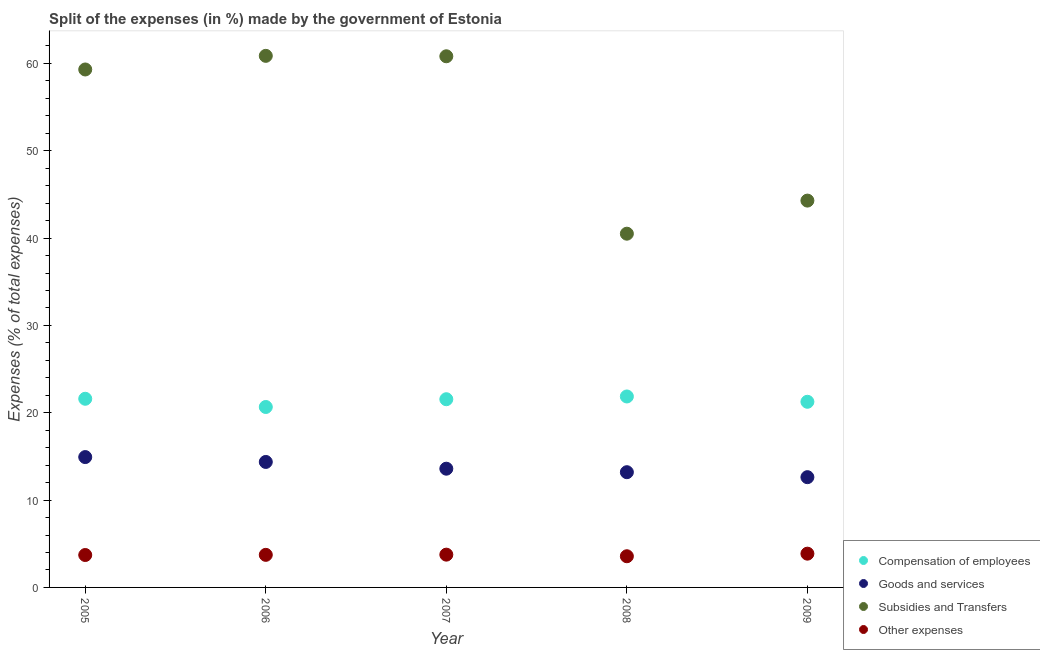How many different coloured dotlines are there?
Offer a terse response. 4. What is the percentage of amount spent on subsidies in 2006?
Make the answer very short. 60.87. Across all years, what is the maximum percentage of amount spent on subsidies?
Offer a terse response. 60.87. Across all years, what is the minimum percentage of amount spent on goods and services?
Your response must be concise. 12.63. In which year was the percentage of amount spent on other expenses maximum?
Keep it short and to the point. 2009. In which year was the percentage of amount spent on other expenses minimum?
Ensure brevity in your answer.  2008. What is the total percentage of amount spent on compensation of employees in the graph?
Ensure brevity in your answer.  106.94. What is the difference between the percentage of amount spent on other expenses in 2005 and that in 2007?
Ensure brevity in your answer.  -0.04. What is the difference between the percentage of amount spent on subsidies in 2006 and the percentage of amount spent on other expenses in 2008?
Your answer should be very brief. 57.3. What is the average percentage of amount spent on other expenses per year?
Keep it short and to the point. 3.73. In the year 2006, what is the difference between the percentage of amount spent on goods and services and percentage of amount spent on compensation of employees?
Ensure brevity in your answer.  -6.29. What is the ratio of the percentage of amount spent on other expenses in 2005 to that in 2007?
Make the answer very short. 0.99. What is the difference between the highest and the second highest percentage of amount spent on subsidies?
Give a very brief answer. 0.05. What is the difference between the highest and the lowest percentage of amount spent on goods and services?
Ensure brevity in your answer.  2.3. Is it the case that in every year, the sum of the percentage of amount spent on compensation of employees and percentage of amount spent on goods and services is greater than the percentage of amount spent on subsidies?
Give a very brief answer. No. Does the percentage of amount spent on goods and services monotonically increase over the years?
Provide a short and direct response. No. Is the percentage of amount spent on compensation of employees strictly greater than the percentage of amount spent on subsidies over the years?
Make the answer very short. No. How many years are there in the graph?
Make the answer very short. 5. Are the values on the major ticks of Y-axis written in scientific E-notation?
Your response must be concise. No. Does the graph contain grids?
Make the answer very short. No. How many legend labels are there?
Give a very brief answer. 4. What is the title of the graph?
Keep it short and to the point. Split of the expenses (in %) made by the government of Estonia. Does "Public sector management" appear as one of the legend labels in the graph?
Ensure brevity in your answer.  No. What is the label or title of the Y-axis?
Ensure brevity in your answer.  Expenses (% of total expenses). What is the Expenses (% of total expenses) in Compensation of employees in 2005?
Provide a succinct answer. 21.6. What is the Expenses (% of total expenses) in Goods and services in 2005?
Offer a terse response. 14.93. What is the Expenses (% of total expenses) in Subsidies and Transfers in 2005?
Provide a short and direct response. 59.31. What is the Expenses (% of total expenses) of Other expenses in 2005?
Your answer should be compact. 3.71. What is the Expenses (% of total expenses) of Compensation of employees in 2006?
Your answer should be compact. 20.66. What is the Expenses (% of total expenses) in Goods and services in 2006?
Ensure brevity in your answer.  14.37. What is the Expenses (% of total expenses) in Subsidies and Transfers in 2006?
Ensure brevity in your answer.  60.87. What is the Expenses (% of total expenses) of Other expenses in 2006?
Offer a terse response. 3.73. What is the Expenses (% of total expenses) in Compensation of employees in 2007?
Give a very brief answer. 21.55. What is the Expenses (% of total expenses) in Goods and services in 2007?
Keep it short and to the point. 13.6. What is the Expenses (% of total expenses) in Subsidies and Transfers in 2007?
Your response must be concise. 60.82. What is the Expenses (% of total expenses) in Other expenses in 2007?
Keep it short and to the point. 3.75. What is the Expenses (% of total expenses) of Compensation of employees in 2008?
Give a very brief answer. 21.87. What is the Expenses (% of total expenses) of Goods and services in 2008?
Your answer should be compact. 13.19. What is the Expenses (% of total expenses) in Subsidies and Transfers in 2008?
Offer a terse response. 40.51. What is the Expenses (% of total expenses) of Other expenses in 2008?
Your response must be concise. 3.57. What is the Expenses (% of total expenses) in Compensation of employees in 2009?
Your response must be concise. 21.26. What is the Expenses (% of total expenses) in Goods and services in 2009?
Provide a succinct answer. 12.63. What is the Expenses (% of total expenses) in Subsidies and Transfers in 2009?
Offer a very short reply. 44.29. What is the Expenses (% of total expenses) in Other expenses in 2009?
Make the answer very short. 3.87. Across all years, what is the maximum Expenses (% of total expenses) in Compensation of employees?
Your response must be concise. 21.87. Across all years, what is the maximum Expenses (% of total expenses) of Goods and services?
Provide a short and direct response. 14.93. Across all years, what is the maximum Expenses (% of total expenses) in Subsidies and Transfers?
Ensure brevity in your answer.  60.87. Across all years, what is the maximum Expenses (% of total expenses) in Other expenses?
Give a very brief answer. 3.87. Across all years, what is the minimum Expenses (% of total expenses) in Compensation of employees?
Offer a terse response. 20.66. Across all years, what is the minimum Expenses (% of total expenses) of Goods and services?
Keep it short and to the point. 12.63. Across all years, what is the minimum Expenses (% of total expenses) in Subsidies and Transfers?
Give a very brief answer. 40.51. Across all years, what is the minimum Expenses (% of total expenses) of Other expenses?
Offer a terse response. 3.57. What is the total Expenses (% of total expenses) in Compensation of employees in the graph?
Make the answer very short. 106.94. What is the total Expenses (% of total expenses) in Goods and services in the graph?
Make the answer very short. 68.71. What is the total Expenses (% of total expenses) of Subsidies and Transfers in the graph?
Provide a short and direct response. 265.8. What is the total Expenses (% of total expenses) of Other expenses in the graph?
Your answer should be compact. 18.63. What is the difference between the Expenses (% of total expenses) in Compensation of employees in 2005 and that in 2006?
Offer a very short reply. 0.94. What is the difference between the Expenses (% of total expenses) of Goods and services in 2005 and that in 2006?
Your answer should be very brief. 0.56. What is the difference between the Expenses (% of total expenses) of Subsidies and Transfers in 2005 and that in 2006?
Your answer should be compact. -1.56. What is the difference between the Expenses (% of total expenses) in Other expenses in 2005 and that in 2006?
Provide a succinct answer. -0.02. What is the difference between the Expenses (% of total expenses) of Compensation of employees in 2005 and that in 2007?
Your response must be concise. 0.05. What is the difference between the Expenses (% of total expenses) of Goods and services in 2005 and that in 2007?
Ensure brevity in your answer.  1.33. What is the difference between the Expenses (% of total expenses) of Subsidies and Transfers in 2005 and that in 2007?
Provide a succinct answer. -1.51. What is the difference between the Expenses (% of total expenses) of Other expenses in 2005 and that in 2007?
Keep it short and to the point. -0.04. What is the difference between the Expenses (% of total expenses) in Compensation of employees in 2005 and that in 2008?
Ensure brevity in your answer.  -0.26. What is the difference between the Expenses (% of total expenses) of Goods and services in 2005 and that in 2008?
Keep it short and to the point. 1.73. What is the difference between the Expenses (% of total expenses) of Subsidies and Transfers in 2005 and that in 2008?
Provide a short and direct response. 18.8. What is the difference between the Expenses (% of total expenses) of Other expenses in 2005 and that in 2008?
Ensure brevity in your answer.  0.14. What is the difference between the Expenses (% of total expenses) in Compensation of employees in 2005 and that in 2009?
Your response must be concise. 0.35. What is the difference between the Expenses (% of total expenses) of Goods and services in 2005 and that in 2009?
Your answer should be compact. 2.3. What is the difference between the Expenses (% of total expenses) of Subsidies and Transfers in 2005 and that in 2009?
Offer a very short reply. 15.01. What is the difference between the Expenses (% of total expenses) in Other expenses in 2005 and that in 2009?
Give a very brief answer. -0.15. What is the difference between the Expenses (% of total expenses) of Compensation of employees in 2006 and that in 2007?
Give a very brief answer. -0.89. What is the difference between the Expenses (% of total expenses) in Goods and services in 2006 and that in 2007?
Your answer should be very brief. 0.77. What is the difference between the Expenses (% of total expenses) in Subsidies and Transfers in 2006 and that in 2007?
Make the answer very short. 0.05. What is the difference between the Expenses (% of total expenses) of Other expenses in 2006 and that in 2007?
Provide a short and direct response. -0.02. What is the difference between the Expenses (% of total expenses) of Compensation of employees in 2006 and that in 2008?
Provide a short and direct response. -1.21. What is the difference between the Expenses (% of total expenses) of Goods and services in 2006 and that in 2008?
Give a very brief answer. 1.17. What is the difference between the Expenses (% of total expenses) of Subsidies and Transfers in 2006 and that in 2008?
Make the answer very short. 20.36. What is the difference between the Expenses (% of total expenses) of Other expenses in 2006 and that in 2008?
Your answer should be compact. 0.16. What is the difference between the Expenses (% of total expenses) of Compensation of employees in 2006 and that in 2009?
Your answer should be very brief. -0.6. What is the difference between the Expenses (% of total expenses) of Goods and services in 2006 and that in 2009?
Your answer should be compact. 1.74. What is the difference between the Expenses (% of total expenses) in Subsidies and Transfers in 2006 and that in 2009?
Keep it short and to the point. 16.58. What is the difference between the Expenses (% of total expenses) of Other expenses in 2006 and that in 2009?
Give a very brief answer. -0.14. What is the difference between the Expenses (% of total expenses) of Compensation of employees in 2007 and that in 2008?
Your answer should be very brief. -0.32. What is the difference between the Expenses (% of total expenses) in Goods and services in 2007 and that in 2008?
Ensure brevity in your answer.  0.4. What is the difference between the Expenses (% of total expenses) of Subsidies and Transfers in 2007 and that in 2008?
Your answer should be very brief. 20.31. What is the difference between the Expenses (% of total expenses) in Other expenses in 2007 and that in 2008?
Ensure brevity in your answer.  0.18. What is the difference between the Expenses (% of total expenses) in Compensation of employees in 2007 and that in 2009?
Your answer should be very brief. 0.29. What is the difference between the Expenses (% of total expenses) of Goods and services in 2007 and that in 2009?
Your response must be concise. 0.97. What is the difference between the Expenses (% of total expenses) in Subsidies and Transfers in 2007 and that in 2009?
Keep it short and to the point. 16.53. What is the difference between the Expenses (% of total expenses) in Other expenses in 2007 and that in 2009?
Give a very brief answer. -0.11. What is the difference between the Expenses (% of total expenses) in Compensation of employees in 2008 and that in 2009?
Give a very brief answer. 0.61. What is the difference between the Expenses (% of total expenses) of Goods and services in 2008 and that in 2009?
Your response must be concise. 0.57. What is the difference between the Expenses (% of total expenses) in Subsidies and Transfers in 2008 and that in 2009?
Your response must be concise. -3.79. What is the difference between the Expenses (% of total expenses) in Other expenses in 2008 and that in 2009?
Offer a very short reply. -0.3. What is the difference between the Expenses (% of total expenses) of Compensation of employees in 2005 and the Expenses (% of total expenses) of Goods and services in 2006?
Offer a terse response. 7.23. What is the difference between the Expenses (% of total expenses) in Compensation of employees in 2005 and the Expenses (% of total expenses) in Subsidies and Transfers in 2006?
Offer a terse response. -39.27. What is the difference between the Expenses (% of total expenses) in Compensation of employees in 2005 and the Expenses (% of total expenses) in Other expenses in 2006?
Provide a short and direct response. 17.87. What is the difference between the Expenses (% of total expenses) in Goods and services in 2005 and the Expenses (% of total expenses) in Subsidies and Transfers in 2006?
Offer a terse response. -45.94. What is the difference between the Expenses (% of total expenses) in Goods and services in 2005 and the Expenses (% of total expenses) in Other expenses in 2006?
Provide a succinct answer. 11.2. What is the difference between the Expenses (% of total expenses) in Subsidies and Transfers in 2005 and the Expenses (% of total expenses) in Other expenses in 2006?
Offer a very short reply. 55.58. What is the difference between the Expenses (% of total expenses) of Compensation of employees in 2005 and the Expenses (% of total expenses) of Goods and services in 2007?
Your response must be concise. 8.01. What is the difference between the Expenses (% of total expenses) in Compensation of employees in 2005 and the Expenses (% of total expenses) in Subsidies and Transfers in 2007?
Your answer should be very brief. -39.22. What is the difference between the Expenses (% of total expenses) in Compensation of employees in 2005 and the Expenses (% of total expenses) in Other expenses in 2007?
Offer a very short reply. 17.85. What is the difference between the Expenses (% of total expenses) in Goods and services in 2005 and the Expenses (% of total expenses) in Subsidies and Transfers in 2007?
Offer a very short reply. -45.89. What is the difference between the Expenses (% of total expenses) of Goods and services in 2005 and the Expenses (% of total expenses) of Other expenses in 2007?
Your answer should be compact. 11.17. What is the difference between the Expenses (% of total expenses) in Subsidies and Transfers in 2005 and the Expenses (% of total expenses) in Other expenses in 2007?
Your response must be concise. 55.55. What is the difference between the Expenses (% of total expenses) in Compensation of employees in 2005 and the Expenses (% of total expenses) in Goods and services in 2008?
Provide a succinct answer. 8.41. What is the difference between the Expenses (% of total expenses) in Compensation of employees in 2005 and the Expenses (% of total expenses) in Subsidies and Transfers in 2008?
Your response must be concise. -18.9. What is the difference between the Expenses (% of total expenses) of Compensation of employees in 2005 and the Expenses (% of total expenses) of Other expenses in 2008?
Give a very brief answer. 18.03. What is the difference between the Expenses (% of total expenses) in Goods and services in 2005 and the Expenses (% of total expenses) in Subsidies and Transfers in 2008?
Offer a terse response. -25.58. What is the difference between the Expenses (% of total expenses) of Goods and services in 2005 and the Expenses (% of total expenses) of Other expenses in 2008?
Your response must be concise. 11.36. What is the difference between the Expenses (% of total expenses) in Subsidies and Transfers in 2005 and the Expenses (% of total expenses) in Other expenses in 2008?
Ensure brevity in your answer.  55.74. What is the difference between the Expenses (% of total expenses) in Compensation of employees in 2005 and the Expenses (% of total expenses) in Goods and services in 2009?
Keep it short and to the point. 8.98. What is the difference between the Expenses (% of total expenses) in Compensation of employees in 2005 and the Expenses (% of total expenses) in Subsidies and Transfers in 2009?
Ensure brevity in your answer.  -22.69. What is the difference between the Expenses (% of total expenses) of Compensation of employees in 2005 and the Expenses (% of total expenses) of Other expenses in 2009?
Give a very brief answer. 17.74. What is the difference between the Expenses (% of total expenses) of Goods and services in 2005 and the Expenses (% of total expenses) of Subsidies and Transfers in 2009?
Provide a succinct answer. -29.37. What is the difference between the Expenses (% of total expenses) in Goods and services in 2005 and the Expenses (% of total expenses) in Other expenses in 2009?
Your answer should be very brief. 11.06. What is the difference between the Expenses (% of total expenses) in Subsidies and Transfers in 2005 and the Expenses (% of total expenses) in Other expenses in 2009?
Give a very brief answer. 55.44. What is the difference between the Expenses (% of total expenses) of Compensation of employees in 2006 and the Expenses (% of total expenses) of Goods and services in 2007?
Your response must be concise. 7.07. What is the difference between the Expenses (% of total expenses) of Compensation of employees in 2006 and the Expenses (% of total expenses) of Subsidies and Transfers in 2007?
Offer a terse response. -40.16. What is the difference between the Expenses (% of total expenses) of Compensation of employees in 2006 and the Expenses (% of total expenses) of Other expenses in 2007?
Keep it short and to the point. 16.91. What is the difference between the Expenses (% of total expenses) of Goods and services in 2006 and the Expenses (% of total expenses) of Subsidies and Transfers in 2007?
Provide a short and direct response. -46.45. What is the difference between the Expenses (% of total expenses) in Goods and services in 2006 and the Expenses (% of total expenses) in Other expenses in 2007?
Make the answer very short. 10.61. What is the difference between the Expenses (% of total expenses) of Subsidies and Transfers in 2006 and the Expenses (% of total expenses) of Other expenses in 2007?
Your answer should be very brief. 57.12. What is the difference between the Expenses (% of total expenses) in Compensation of employees in 2006 and the Expenses (% of total expenses) in Goods and services in 2008?
Your answer should be compact. 7.47. What is the difference between the Expenses (% of total expenses) in Compensation of employees in 2006 and the Expenses (% of total expenses) in Subsidies and Transfers in 2008?
Your response must be concise. -19.84. What is the difference between the Expenses (% of total expenses) in Compensation of employees in 2006 and the Expenses (% of total expenses) in Other expenses in 2008?
Provide a short and direct response. 17.09. What is the difference between the Expenses (% of total expenses) in Goods and services in 2006 and the Expenses (% of total expenses) in Subsidies and Transfers in 2008?
Keep it short and to the point. -26.14. What is the difference between the Expenses (% of total expenses) of Goods and services in 2006 and the Expenses (% of total expenses) of Other expenses in 2008?
Your answer should be compact. 10.8. What is the difference between the Expenses (% of total expenses) in Subsidies and Transfers in 2006 and the Expenses (% of total expenses) in Other expenses in 2008?
Keep it short and to the point. 57.3. What is the difference between the Expenses (% of total expenses) in Compensation of employees in 2006 and the Expenses (% of total expenses) in Goods and services in 2009?
Offer a very short reply. 8.04. What is the difference between the Expenses (% of total expenses) of Compensation of employees in 2006 and the Expenses (% of total expenses) of Subsidies and Transfers in 2009?
Your answer should be very brief. -23.63. What is the difference between the Expenses (% of total expenses) in Compensation of employees in 2006 and the Expenses (% of total expenses) in Other expenses in 2009?
Your answer should be very brief. 16.79. What is the difference between the Expenses (% of total expenses) of Goods and services in 2006 and the Expenses (% of total expenses) of Subsidies and Transfers in 2009?
Provide a succinct answer. -29.93. What is the difference between the Expenses (% of total expenses) in Goods and services in 2006 and the Expenses (% of total expenses) in Other expenses in 2009?
Ensure brevity in your answer.  10.5. What is the difference between the Expenses (% of total expenses) in Subsidies and Transfers in 2006 and the Expenses (% of total expenses) in Other expenses in 2009?
Ensure brevity in your answer.  57. What is the difference between the Expenses (% of total expenses) in Compensation of employees in 2007 and the Expenses (% of total expenses) in Goods and services in 2008?
Give a very brief answer. 8.36. What is the difference between the Expenses (% of total expenses) of Compensation of employees in 2007 and the Expenses (% of total expenses) of Subsidies and Transfers in 2008?
Provide a succinct answer. -18.95. What is the difference between the Expenses (% of total expenses) in Compensation of employees in 2007 and the Expenses (% of total expenses) in Other expenses in 2008?
Keep it short and to the point. 17.98. What is the difference between the Expenses (% of total expenses) in Goods and services in 2007 and the Expenses (% of total expenses) in Subsidies and Transfers in 2008?
Keep it short and to the point. -26.91. What is the difference between the Expenses (% of total expenses) of Goods and services in 2007 and the Expenses (% of total expenses) of Other expenses in 2008?
Make the answer very short. 10.03. What is the difference between the Expenses (% of total expenses) in Subsidies and Transfers in 2007 and the Expenses (% of total expenses) in Other expenses in 2008?
Your answer should be very brief. 57.25. What is the difference between the Expenses (% of total expenses) of Compensation of employees in 2007 and the Expenses (% of total expenses) of Goods and services in 2009?
Offer a terse response. 8.93. What is the difference between the Expenses (% of total expenses) of Compensation of employees in 2007 and the Expenses (% of total expenses) of Subsidies and Transfers in 2009?
Your answer should be very brief. -22.74. What is the difference between the Expenses (% of total expenses) of Compensation of employees in 2007 and the Expenses (% of total expenses) of Other expenses in 2009?
Keep it short and to the point. 17.68. What is the difference between the Expenses (% of total expenses) in Goods and services in 2007 and the Expenses (% of total expenses) in Subsidies and Transfers in 2009?
Offer a terse response. -30.7. What is the difference between the Expenses (% of total expenses) in Goods and services in 2007 and the Expenses (% of total expenses) in Other expenses in 2009?
Ensure brevity in your answer.  9.73. What is the difference between the Expenses (% of total expenses) of Subsidies and Transfers in 2007 and the Expenses (% of total expenses) of Other expenses in 2009?
Keep it short and to the point. 56.95. What is the difference between the Expenses (% of total expenses) of Compensation of employees in 2008 and the Expenses (% of total expenses) of Goods and services in 2009?
Offer a terse response. 9.24. What is the difference between the Expenses (% of total expenses) in Compensation of employees in 2008 and the Expenses (% of total expenses) in Subsidies and Transfers in 2009?
Make the answer very short. -22.43. What is the difference between the Expenses (% of total expenses) in Compensation of employees in 2008 and the Expenses (% of total expenses) in Other expenses in 2009?
Provide a succinct answer. 18. What is the difference between the Expenses (% of total expenses) of Goods and services in 2008 and the Expenses (% of total expenses) of Subsidies and Transfers in 2009?
Make the answer very short. -31.1. What is the difference between the Expenses (% of total expenses) of Goods and services in 2008 and the Expenses (% of total expenses) of Other expenses in 2009?
Offer a very short reply. 9.33. What is the difference between the Expenses (% of total expenses) in Subsidies and Transfers in 2008 and the Expenses (% of total expenses) in Other expenses in 2009?
Offer a terse response. 36.64. What is the average Expenses (% of total expenses) of Compensation of employees per year?
Provide a short and direct response. 21.39. What is the average Expenses (% of total expenses) of Goods and services per year?
Provide a succinct answer. 13.74. What is the average Expenses (% of total expenses) in Subsidies and Transfers per year?
Offer a terse response. 53.16. What is the average Expenses (% of total expenses) of Other expenses per year?
Provide a short and direct response. 3.73. In the year 2005, what is the difference between the Expenses (% of total expenses) of Compensation of employees and Expenses (% of total expenses) of Goods and services?
Provide a short and direct response. 6.68. In the year 2005, what is the difference between the Expenses (% of total expenses) in Compensation of employees and Expenses (% of total expenses) in Subsidies and Transfers?
Your answer should be compact. -37.71. In the year 2005, what is the difference between the Expenses (% of total expenses) of Compensation of employees and Expenses (% of total expenses) of Other expenses?
Offer a terse response. 17.89. In the year 2005, what is the difference between the Expenses (% of total expenses) in Goods and services and Expenses (% of total expenses) in Subsidies and Transfers?
Offer a very short reply. -44.38. In the year 2005, what is the difference between the Expenses (% of total expenses) in Goods and services and Expenses (% of total expenses) in Other expenses?
Keep it short and to the point. 11.21. In the year 2005, what is the difference between the Expenses (% of total expenses) of Subsidies and Transfers and Expenses (% of total expenses) of Other expenses?
Ensure brevity in your answer.  55.6. In the year 2006, what is the difference between the Expenses (% of total expenses) of Compensation of employees and Expenses (% of total expenses) of Goods and services?
Your answer should be very brief. 6.29. In the year 2006, what is the difference between the Expenses (% of total expenses) in Compensation of employees and Expenses (% of total expenses) in Subsidies and Transfers?
Give a very brief answer. -40.21. In the year 2006, what is the difference between the Expenses (% of total expenses) of Compensation of employees and Expenses (% of total expenses) of Other expenses?
Provide a succinct answer. 16.93. In the year 2006, what is the difference between the Expenses (% of total expenses) of Goods and services and Expenses (% of total expenses) of Subsidies and Transfers?
Your answer should be compact. -46.5. In the year 2006, what is the difference between the Expenses (% of total expenses) of Goods and services and Expenses (% of total expenses) of Other expenses?
Ensure brevity in your answer.  10.64. In the year 2006, what is the difference between the Expenses (% of total expenses) in Subsidies and Transfers and Expenses (% of total expenses) in Other expenses?
Make the answer very short. 57.14. In the year 2007, what is the difference between the Expenses (% of total expenses) in Compensation of employees and Expenses (% of total expenses) in Goods and services?
Provide a short and direct response. 7.96. In the year 2007, what is the difference between the Expenses (% of total expenses) of Compensation of employees and Expenses (% of total expenses) of Subsidies and Transfers?
Your answer should be compact. -39.27. In the year 2007, what is the difference between the Expenses (% of total expenses) of Compensation of employees and Expenses (% of total expenses) of Other expenses?
Your answer should be very brief. 17.8. In the year 2007, what is the difference between the Expenses (% of total expenses) of Goods and services and Expenses (% of total expenses) of Subsidies and Transfers?
Make the answer very short. -47.22. In the year 2007, what is the difference between the Expenses (% of total expenses) of Goods and services and Expenses (% of total expenses) of Other expenses?
Your answer should be very brief. 9.84. In the year 2007, what is the difference between the Expenses (% of total expenses) in Subsidies and Transfers and Expenses (% of total expenses) in Other expenses?
Keep it short and to the point. 57.07. In the year 2008, what is the difference between the Expenses (% of total expenses) in Compensation of employees and Expenses (% of total expenses) in Goods and services?
Your response must be concise. 8.67. In the year 2008, what is the difference between the Expenses (% of total expenses) of Compensation of employees and Expenses (% of total expenses) of Subsidies and Transfers?
Offer a very short reply. -18.64. In the year 2008, what is the difference between the Expenses (% of total expenses) in Compensation of employees and Expenses (% of total expenses) in Other expenses?
Ensure brevity in your answer.  18.3. In the year 2008, what is the difference between the Expenses (% of total expenses) in Goods and services and Expenses (% of total expenses) in Subsidies and Transfers?
Offer a terse response. -27.31. In the year 2008, what is the difference between the Expenses (% of total expenses) in Goods and services and Expenses (% of total expenses) in Other expenses?
Keep it short and to the point. 9.62. In the year 2008, what is the difference between the Expenses (% of total expenses) of Subsidies and Transfers and Expenses (% of total expenses) of Other expenses?
Offer a terse response. 36.94. In the year 2009, what is the difference between the Expenses (% of total expenses) of Compensation of employees and Expenses (% of total expenses) of Goods and services?
Provide a succinct answer. 8.63. In the year 2009, what is the difference between the Expenses (% of total expenses) of Compensation of employees and Expenses (% of total expenses) of Subsidies and Transfers?
Provide a succinct answer. -23.04. In the year 2009, what is the difference between the Expenses (% of total expenses) in Compensation of employees and Expenses (% of total expenses) in Other expenses?
Give a very brief answer. 17.39. In the year 2009, what is the difference between the Expenses (% of total expenses) in Goods and services and Expenses (% of total expenses) in Subsidies and Transfers?
Offer a very short reply. -31.67. In the year 2009, what is the difference between the Expenses (% of total expenses) of Goods and services and Expenses (% of total expenses) of Other expenses?
Your answer should be compact. 8.76. In the year 2009, what is the difference between the Expenses (% of total expenses) in Subsidies and Transfers and Expenses (% of total expenses) in Other expenses?
Make the answer very short. 40.43. What is the ratio of the Expenses (% of total expenses) in Compensation of employees in 2005 to that in 2006?
Provide a succinct answer. 1.05. What is the ratio of the Expenses (% of total expenses) in Goods and services in 2005 to that in 2006?
Ensure brevity in your answer.  1.04. What is the ratio of the Expenses (% of total expenses) in Subsidies and Transfers in 2005 to that in 2006?
Ensure brevity in your answer.  0.97. What is the ratio of the Expenses (% of total expenses) of Other expenses in 2005 to that in 2006?
Your answer should be very brief. 0.99. What is the ratio of the Expenses (% of total expenses) in Goods and services in 2005 to that in 2007?
Provide a short and direct response. 1.1. What is the ratio of the Expenses (% of total expenses) in Subsidies and Transfers in 2005 to that in 2007?
Offer a very short reply. 0.98. What is the ratio of the Expenses (% of total expenses) in Goods and services in 2005 to that in 2008?
Make the answer very short. 1.13. What is the ratio of the Expenses (% of total expenses) in Subsidies and Transfers in 2005 to that in 2008?
Give a very brief answer. 1.46. What is the ratio of the Expenses (% of total expenses) of Other expenses in 2005 to that in 2008?
Offer a very short reply. 1.04. What is the ratio of the Expenses (% of total expenses) of Compensation of employees in 2005 to that in 2009?
Give a very brief answer. 1.02. What is the ratio of the Expenses (% of total expenses) of Goods and services in 2005 to that in 2009?
Provide a short and direct response. 1.18. What is the ratio of the Expenses (% of total expenses) in Subsidies and Transfers in 2005 to that in 2009?
Provide a succinct answer. 1.34. What is the ratio of the Expenses (% of total expenses) in Other expenses in 2005 to that in 2009?
Offer a very short reply. 0.96. What is the ratio of the Expenses (% of total expenses) of Compensation of employees in 2006 to that in 2007?
Your answer should be very brief. 0.96. What is the ratio of the Expenses (% of total expenses) of Goods and services in 2006 to that in 2007?
Provide a succinct answer. 1.06. What is the ratio of the Expenses (% of total expenses) of Subsidies and Transfers in 2006 to that in 2007?
Give a very brief answer. 1. What is the ratio of the Expenses (% of total expenses) of Compensation of employees in 2006 to that in 2008?
Your response must be concise. 0.94. What is the ratio of the Expenses (% of total expenses) in Goods and services in 2006 to that in 2008?
Provide a short and direct response. 1.09. What is the ratio of the Expenses (% of total expenses) in Subsidies and Transfers in 2006 to that in 2008?
Keep it short and to the point. 1.5. What is the ratio of the Expenses (% of total expenses) in Other expenses in 2006 to that in 2008?
Keep it short and to the point. 1.04. What is the ratio of the Expenses (% of total expenses) in Compensation of employees in 2006 to that in 2009?
Provide a succinct answer. 0.97. What is the ratio of the Expenses (% of total expenses) of Goods and services in 2006 to that in 2009?
Offer a terse response. 1.14. What is the ratio of the Expenses (% of total expenses) in Subsidies and Transfers in 2006 to that in 2009?
Offer a very short reply. 1.37. What is the ratio of the Expenses (% of total expenses) of Other expenses in 2006 to that in 2009?
Ensure brevity in your answer.  0.96. What is the ratio of the Expenses (% of total expenses) of Compensation of employees in 2007 to that in 2008?
Ensure brevity in your answer.  0.99. What is the ratio of the Expenses (% of total expenses) of Goods and services in 2007 to that in 2008?
Your response must be concise. 1.03. What is the ratio of the Expenses (% of total expenses) of Subsidies and Transfers in 2007 to that in 2008?
Provide a succinct answer. 1.5. What is the ratio of the Expenses (% of total expenses) of Other expenses in 2007 to that in 2008?
Provide a short and direct response. 1.05. What is the ratio of the Expenses (% of total expenses) in Compensation of employees in 2007 to that in 2009?
Give a very brief answer. 1.01. What is the ratio of the Expenses (% of total expenses) of Subsidies and Transfers in 2007 to that in 2009?
Make the answer very short. 1.37. What is the ratio of the Expenses (% of total expenses) of Other expenses in 2007 to that in 2009?
Your response must be concise. 0.97. What is the ratio of the Expenses (% of total expenses) in Compensation of employees in 2008 to that in 2009?
Offer a terse response. 1.03. What is the ratio of the Expenses (% of total expenses) in Goods and services in 2008 to that in 2009?
Provide a succinct answer. 1.05. What is the ratio of the Expenses (% of total expenses) in Subsidies and Transfers in 2008 to that in 2009?
Your answer should be compact. 0.91. What is the ratio of the Expenses (% of total expenses) in Other expenses in 2008 to that in 2009?
Your response must be concise. 0.92. What is the difference between the highest and the second highest Expenses (% of total expenses) in Compensation of employees?
Ensure brevity in your answer.  0.26. What is the difference between the highest and the second highest Expenses (% of total expenses) in Goods and services?
Your response must be concise. 0.56. What is the difference between the highest and the second highest Expenses (% of total expenses) of Subsidies and Transfers?
Offer a terse response. 0.05. What is the difference between the highest and the second highest Expenses (% of total expenses) of Other expenses?
Your answer should be compact. 0.11. What is the difference between the highest and the lowest Expenses (% of total expenses) in Compensation of employees?
Ensure brevity in your answer.  1.21. What is the difference between the highest and the lowest Expenses (% of total expenses) of Goods and services?
Ensure brevity in your answer.  2.3. What is the difference between the highest and the lowest Expenses (% of total expenses) in Subsidies and Transfers?
Your answer should be very brief. 20.36. What is the difference between the highest and the lowest Expenses (% of total expenses) in Other expenses?
Provide a succinct answer. 0.3. 